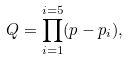<formula> <loc_0><loc_0><loc_500><loc_500>Q = \prod _ { i = 1 } ^ { i = 5 } ( p - p _ { i } ) ,</formula> 